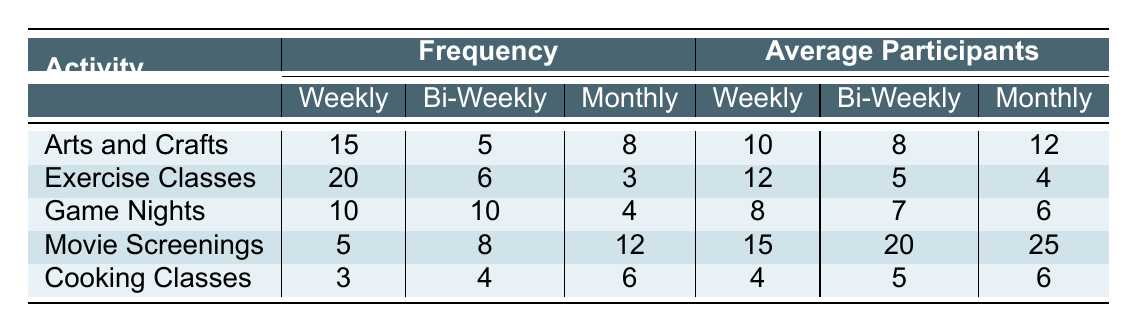What is the frequency of Exercise Classes held bi-weekly? The table indicates that Exercise Classes are held bi-weekly with a frequency count of 6.
Answer: 6 How many participants are there on average in Cooking Classes held weekly? According to the table, the average number of participants in Cooking Classes held weekly is 4.
Answer: 4 Is the frequency of Arts and Crafts sessions higher than that of Game Nights for monthly events? For Arts and Crafts, the monthly frequency is 8, while for Game Nights it is 4. Since 8 is greater than 4, the statement is true.
Answer: Yes Which activity has the highest average number of participants in its monthly sessions? Looking at the monthly average participants, Movie Screenings has the highest number with 25 participants, compared to 12 in Arts and Crafts, 4 in Exercise Classes, 6 in Game Nights, and 6 in Cooking Classes.
Answer: Movie Screenings What’s the total frequency of Game Nights across all timeframes? To find the total frequency of Game Nights, add the counts from all timeframes: 10 (weekly) + 10 (bi-weekly) + 4 (monthly) = 24.
Answer: 24 Are there more average participants in Movie Screenings held bi-weekly than in Exercise Classes held weekly? For Movie Screenings bi-weekly, there are 20 average participants, and for Exercise Classes weekly, there are 12 average participants. Since 20 is greater than 12, the statement is true.
Answer: Yes What is the difference in the number of average participants between Arts and Crafts monthly and Cooking Classes monthly? The average participants for Arts and Crafts in the monthly sessions is 12, while for Cooking Classes it is 6. The difference is calculated as 12 - 6 = 6.
Answer: 6 How many more Exercise Classes are held weekly than monthly? The table shows that there are 20 Exercise Classes held weekly and only 3 held monthly. The difference is 20 - 3 = 17.
Answer: 17 What is the total number of Cooking Classes across all frequencies? The total frequency of Cooking Classes is calculated as follows: 3 (weekly) + 4 (bi-weekly) + 6 (monthly) = 13.
Answer: 13 